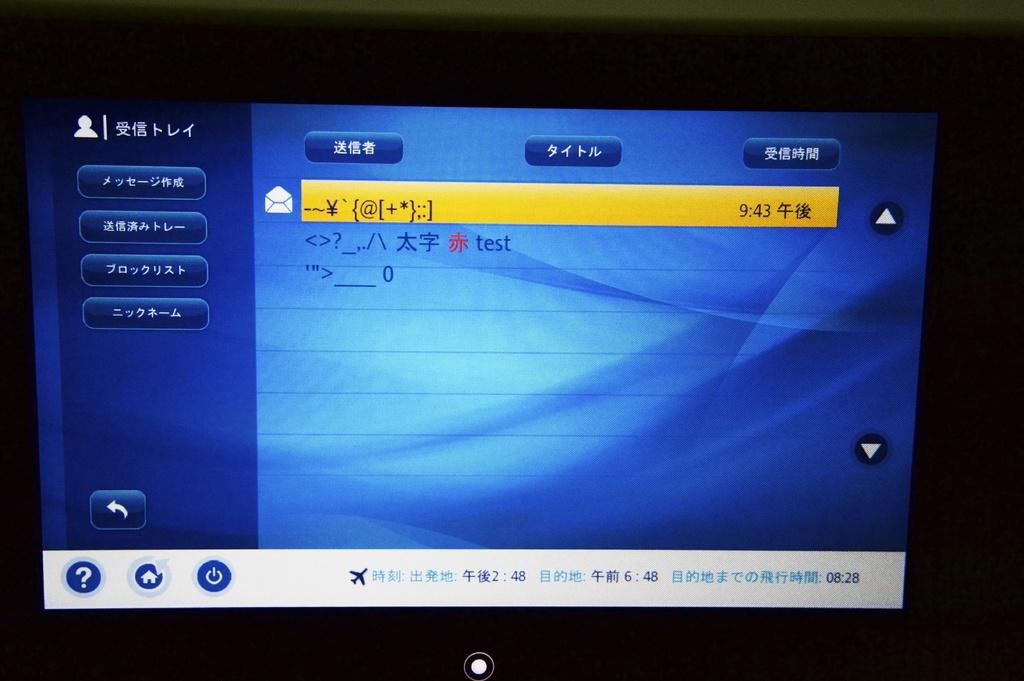<image>
Provide a brief description of the given image. A blue tv screen with writing on it and the time 9:43 displayed in a yellow rectangle 